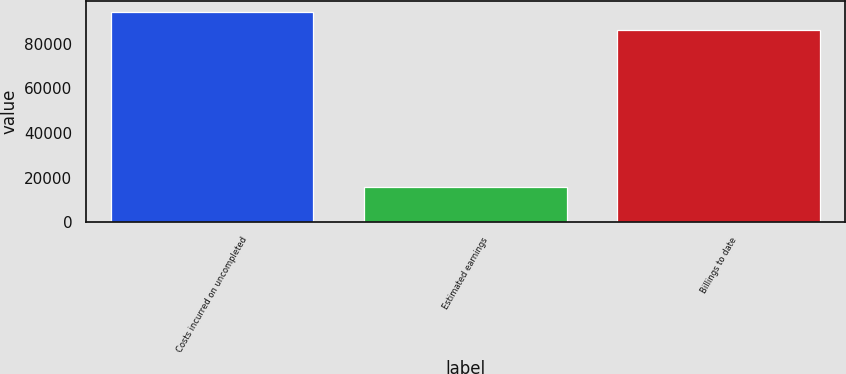Convert chart to OTSL. <chart><loc_0><loc_0><loc_500><loc_500><bar_chart><fcel>Costs incurred on uncompleted<fcel>Estimated earnings<fcel>Billings to date<nl><fcel>94323<fcel>15609<fcel>86139<nl></chart> 